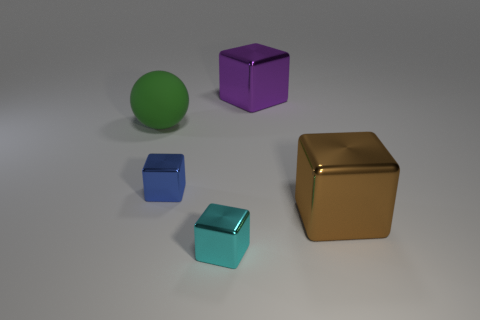Subtract all small blue cubes. How many cubes are left? 3 Add 3 large green matte things. How many objects exist? 8 Subtract all cyan blocks. How many blocks are left? 3 Subtract all cubes. How many objects are left? 1 Subtract all red blocks. Subtract all brown cylinders. How many blocks are left? 4 Subtract all large blue matte objects. Subtract all large balls. How many objects are left? 4 Add 2 blue objects. How many blue objects are left? 3 Add 2 yellow shiny spheres. How many yellow shiny spheres exist? 2 Subtract 0 cyan cylinders. How many objects are left? 5 